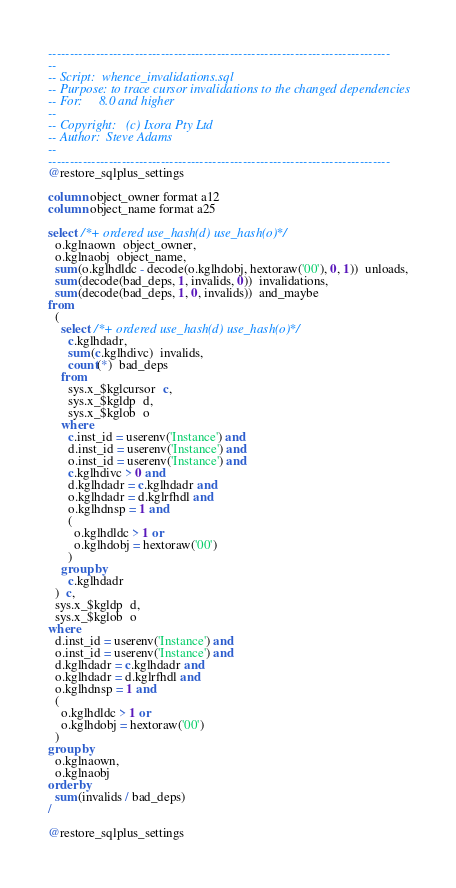<code> <loc_0><loc_0><loc_500><loc_500><_SQL_>-------------------------------------------------------------------------------
--
-- Script:	whence_invalidations.sql
-- Purpose:	to trace cursor invalidations to the changed dependencies
-- For:		8.0 and higher
--
-- Copyright:	(c) Ixora Pty Ltd
-- Author:	Steve Adams
--
-------------------------------------------------------------------------------
@restore_sqlplus_settings

column object_owner format a12
column object_name format a25

select /*+ ordered use_hash(d) use_hash(o) */
  o.kglnaown  object_owner,
  o.kglnaobj  object_name,
  sum(o.kglhdldc - decode(o.kglhdobj, hextoraw('00'), 0, 1))  unloads,
  sum(decode(bad_deps, 1, invalids, 0))  invalidations,
  sum(decode(bad_deps, 1, 0, invalids))  and_maybe
from
  (
    select /*+ ordered use_hash(d) use_hash(o) */
      c.kglhdadr,
      sum(c.kglhdivc)  invalids,
      count(*)  bad_deps
    from
      sys.x_$kglcursor  c,
      sys.x_$kgldp  d,
      sys.x_$kglob  o
    where
      c.inst_id = userenv('Instance') and
      d.inst_id = userenv('Instance') and
      o.inst_id = userenv('Instance') and
      c.kglhdivc > 0 and
      d.kglhdadr = c.kglhdadr and
      o.kglhdadr = d.kglrfhdl and
      o.kglhdnsp = 1 and
      (
        o.kglhdldc > 1 or
        o.kglhdobj = hextoraw('00')
      )
    group by
      c.kglhdadr
  )  c,
  sys.x_$kgldp  d,
  sys.x_$kglob  o
where
  d.inst_id = userenv('Instance') and
  o.inst_id = userenv('Instance') and
  d.kglhdadr = c.kglhdadr and
  o.kglhdadr = d.kglrfhdl and
  o.kglhdnsp = 1 and
  (
    o.kglhdldc > 1 or
    o.kglhdobj = hextoraw('00')
  )
group by
  o.kglnaown,
  o.kglnaobj
order by
  sum(invalids / bad_deps)
/

@restore_sqlplus_settings
</code> 